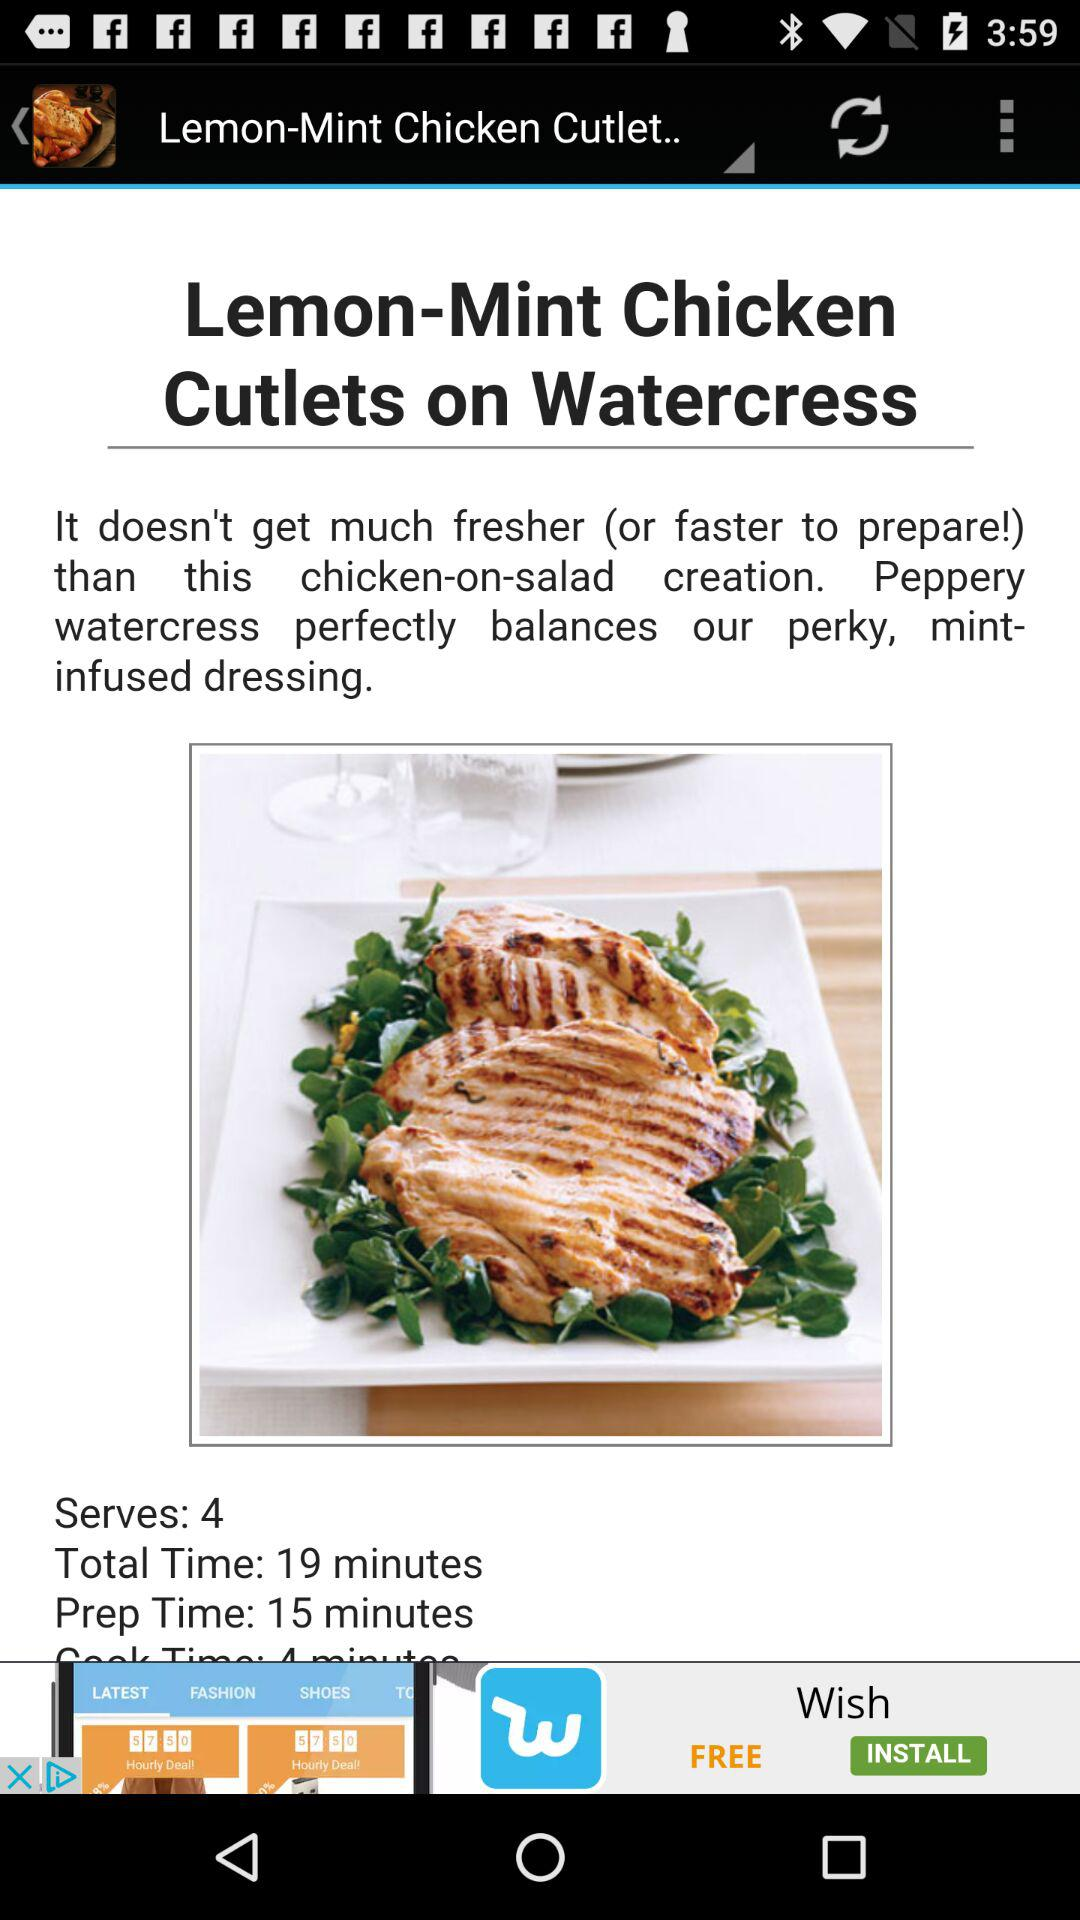How many more minutes are needed for the total time than the prep time?
Answer the question using a single word or phrase. 4 